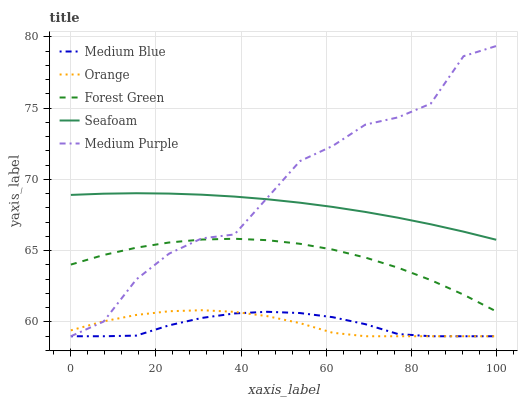Does Forest Green have the minimum area under the curve?
Answer yes or no. No. Does Forest Green have the maximum area under the curve?
Answer yes or no. No. Is Forest Green the smoothest?
Answer yes or no. No. Is Forest Green the roughest?
Answer yes or no. No. Does Forest Green have the lowest value?
Answer yes or no. No. Does Forest Green have the highest value?
Answer yes or no. No. Is Orange less than Seafoam?
Answer yes or no. Yes. Is Seafoam greater than Orange?
Answer yes or no. Yes. Does Orange intersect Seafoam?
Answer yes or no. No. 